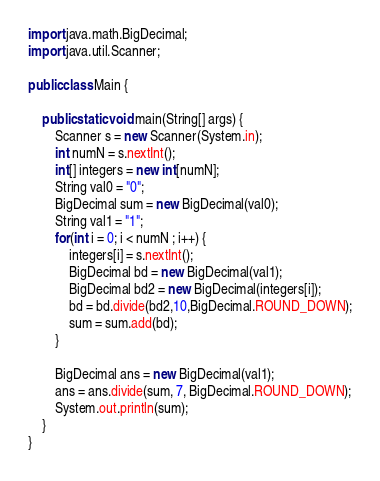<code> <loc_0><loc_0><loc_500><loc_500><_Java_>
import java.math.BigDecimal;
import java.util.Scanner;

public class Main {

	public static void main(String[] args) {
		Scanner s = new Scanner(System.in);
		int numN = s.nextInt();
		int[] integers = new int[numN];
		String val0 = "0";
		BigDecimal sum = new BigDecimal(val0);
		String val1 = "1";
		for(int i = 0; i < numN ; i++) {
			integers[i] = s.nextInt();
			BigDecimal bd = new BigDecimal(val1);
			BigDecimal bd2 = new BigDecimal(integers[i]);
			bd = bd.divide(bd2,10,BigDecimal.ROUND_DOWN);
			sum = sum.add(bd);
		}
		
		BigDecimal ans = new BigDecimal(val1);
		ans = ans.divide(sum, 7, BigDecimal.ROUND_DOWN);
		System.out.println(sum);
	}
}</code> 